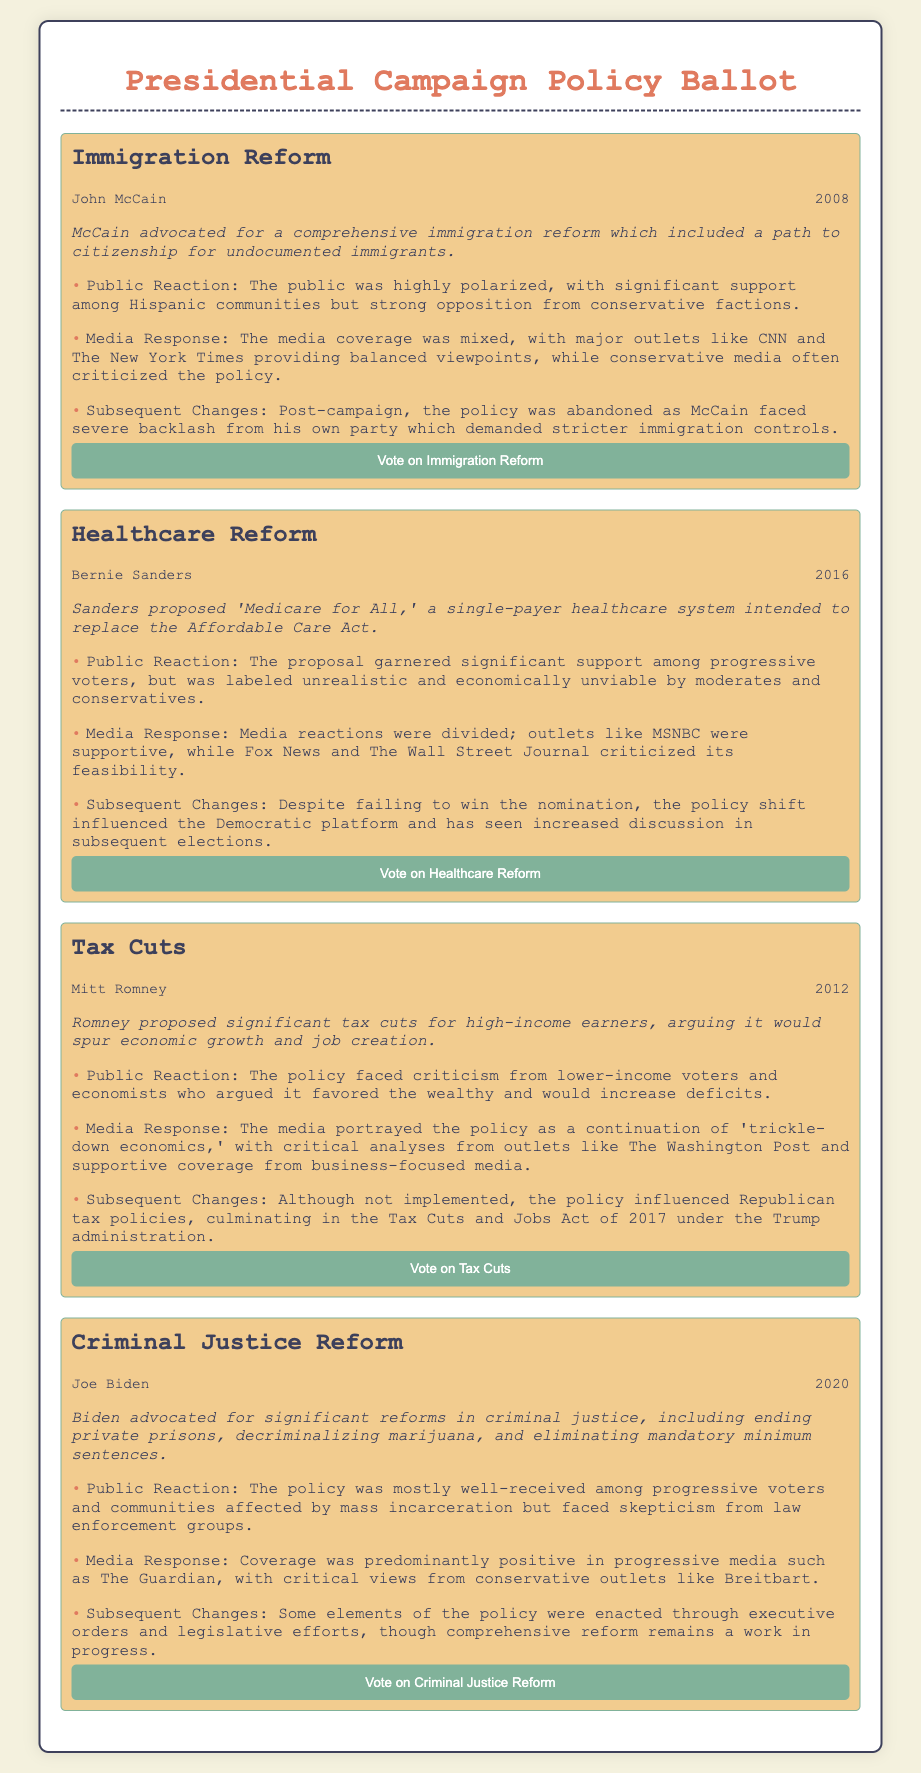What policy did John McCain advocate for in 2008? The document states McCain advocated for comprehensive immigration reform.
Answer: Immigration Reform What was the public reaction to Bernie Sanders' healthcare proposal? The document indicates the proposal garnered significant support among progressive voters.
Answer: Significant support Which candidate proposed tax cuts in 2012? The document identifies Mitt Romney as the candidate who proposed tax cuts.
Answer: Mitt Romney What year did Joe Biden advocate for criminal justice reform? The document specifies that Biden advocated for this reform in 2020.
Answer: 2020 What type of media response did the immigration reform receive? The media coverage was mixed, with major outlets offering balanced viewpoints.
Answer: Mixed What was a significant concern regarding Romney's proposed tax cuts? The document mentions criticism from lower-income voters and economists.
Answer: Criticism Which policy influenced the Democratic platform due to its discussion in later elections? The document notes that Sanders' healthcare reform influenced the Democratic platform.
Answer: Healthcare Reform What was the outcome of Biden's criminal justice reform efforts? The document states some elements were enacted, but comprehensive reform remains a work in progress.
Answer: Work in progress What type of policy did McCain's immigration proposal include for undocumented immigrants? The document states it included a path to citizenship.
Answer: Path to citizenship 